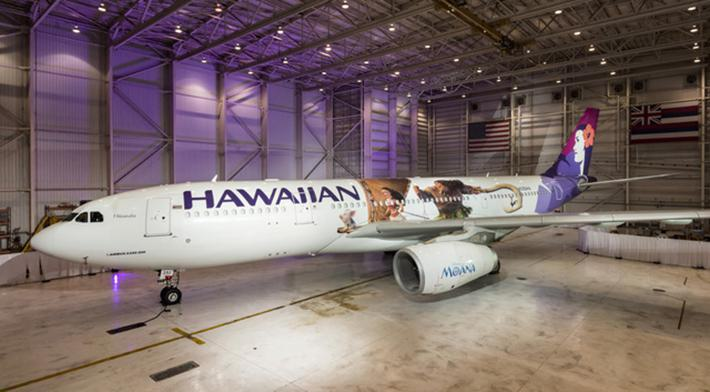How many unicorns are there in the image? There are no unicorns in the image, as the image features an airplane exhibited in a hangar. The absence of any mythical elements suggests the image is grounded in a modern, realistic setting. 